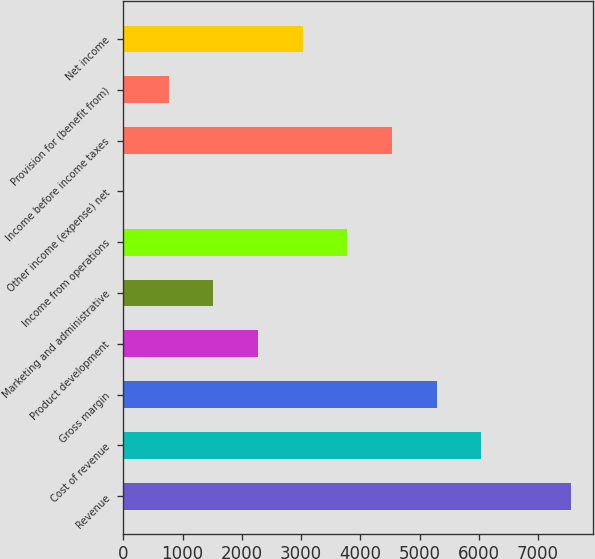Convert chart to OTSL. <chart><loc_0><loc_0><loc_500><loc_500><bar_chart><fcel>Revenue<fcel>Cost of revenue<fcel>Gross margin<fcel>Product development<fcel>Marketing and administrative<fcel>Income from operations<fcel>Other income (expense) net<fcel>Income before income taxes<fcel>Provision for (benefit from)<fcel>Net income<nl><fcel>7553<fcel>6044.4<fcel>5290.1<fcel>2272.9<fcel>1518.6<fcel>3781.5<fcel>10<fcel>4535.8<fcel>764.3<fcel>3027.2<nl></chart> 